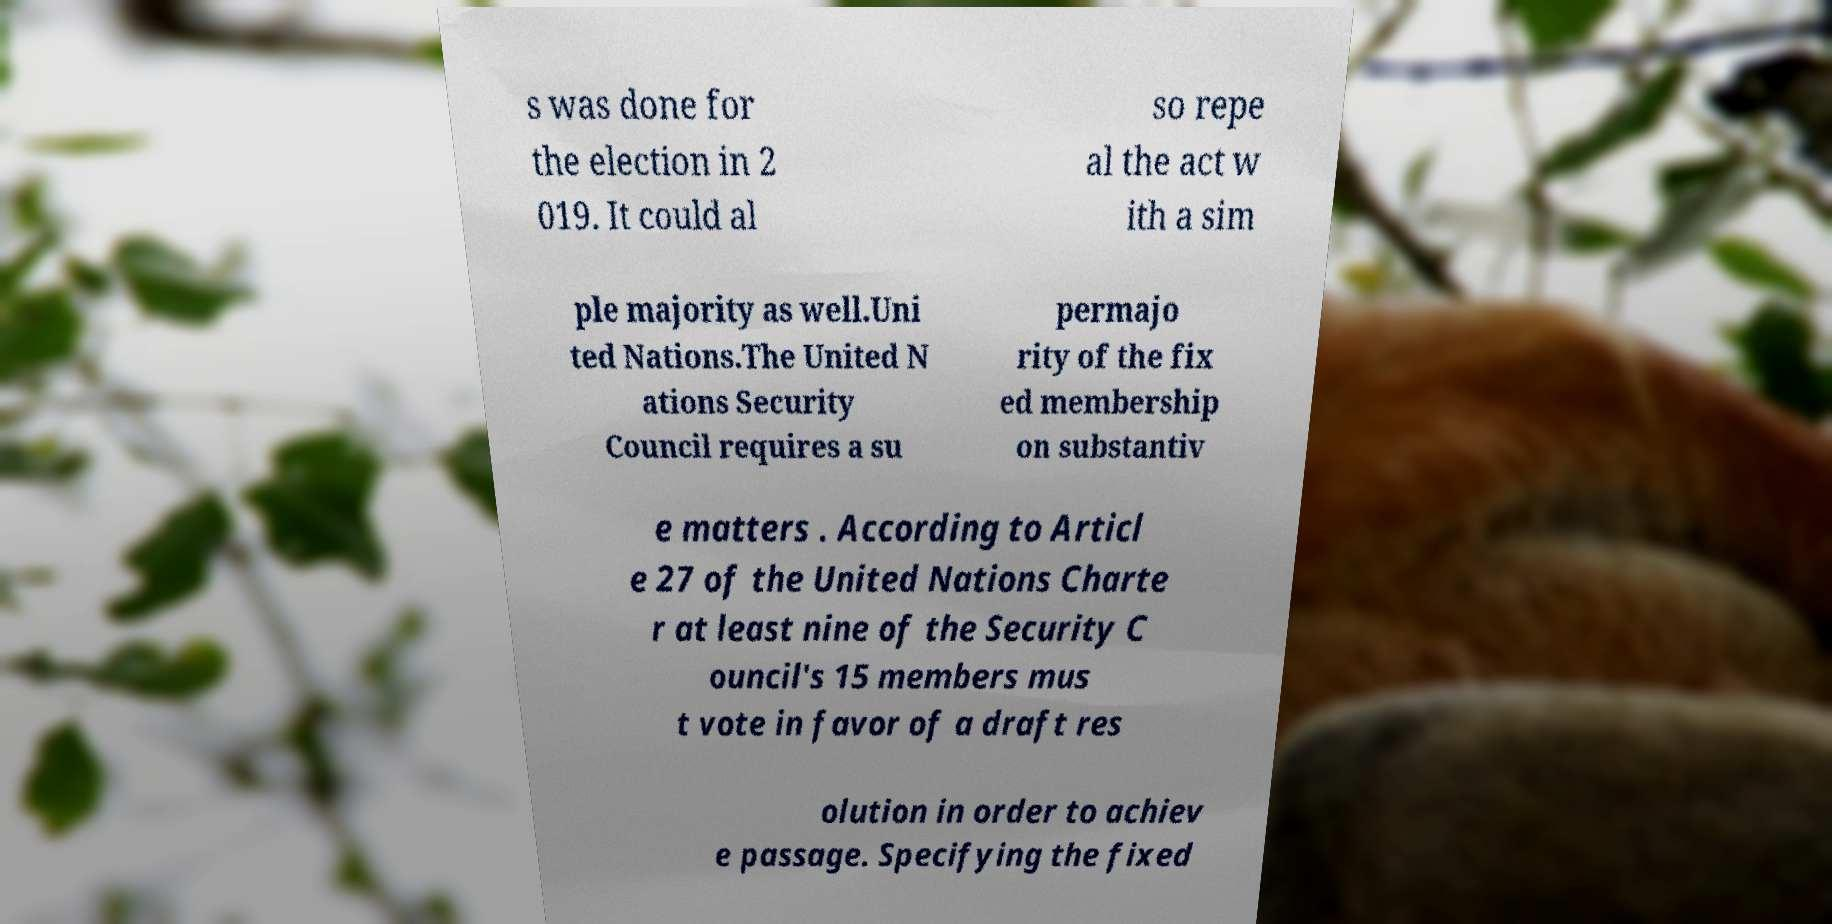Can you read and provide the text displayed in the image?This photo seems to have some interesting text. Can you extract and type it out for me? s was done for the election in 2 019. It could al so repe al the act w ith a sim ple majority as well.Uni ted Nations.The United N ations Security Council requires a su permajo rity of the fix ed membership on substantiv e matters . According to Articl e 27 of the United Nations Charte r at least nine of the Security C ouncil's 15 members mus t vote in favor of a draft res olution in order to achiev e passage. Specifying the fixed 